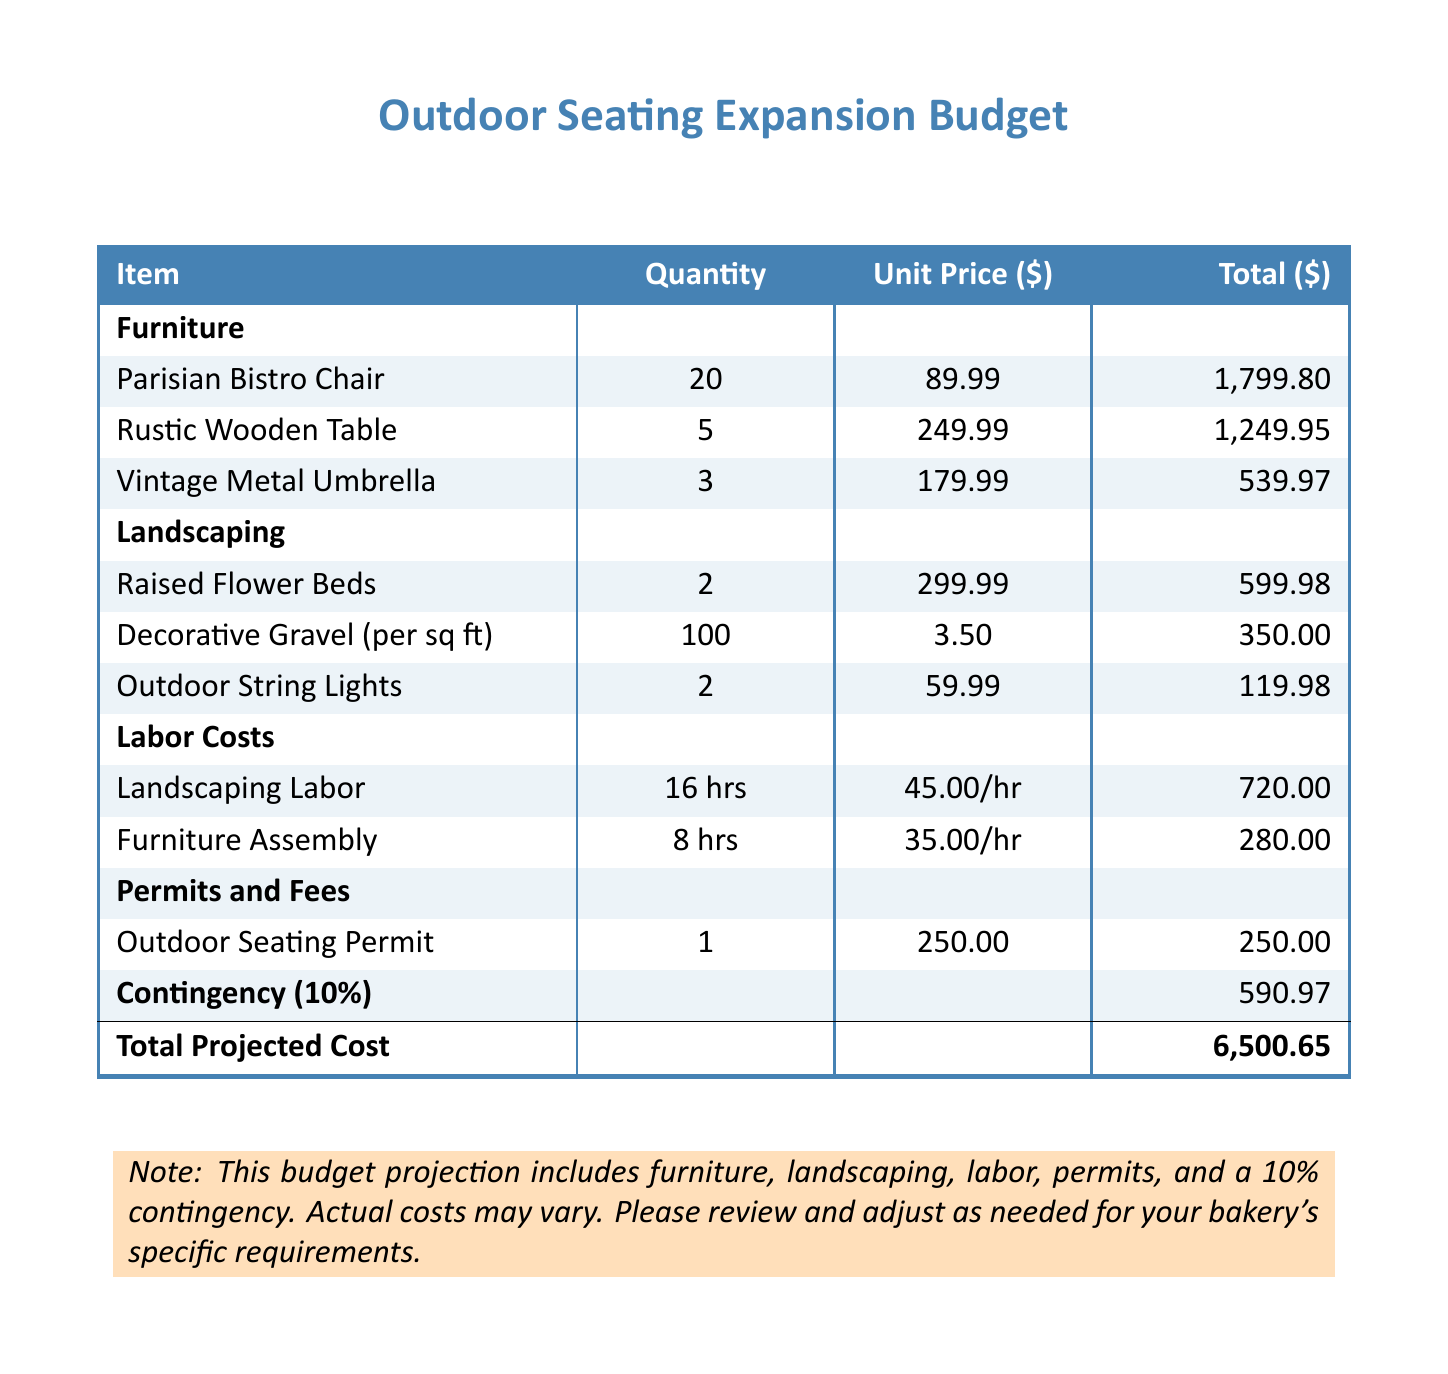What is the total projected cost? The total projected cost is stated at the bottom of the budget table as the final sum of all costs, which includes furniture, landscaping, labor, permits, and contingency.
Answer: 6,500.65 How many Rustic Wooden Tables are included? The quantity of Rustic Wooden Tables is listed under the furniture section of the budget.
Answer: 5 What is the unit price of a Parisian Bistro Chair? The unit price for a Parisian Bistro Chair can be found in the furniture section, next to the item listed.
Answer: 89.99 What is the total cost for Decorative Gravel? The total cost for Decorative Gravel is calculated by multiplying the quantity by the unit price, which is detailed in the budget.
Answer: 350.00 How much does Landscaping Labor cost per hour? The hourly rate for Landscaping Labor can be found in the labor costs section of the document.
Answer: 45.00 What is included in the contingency? The contingency is a percentage added to the total costs to cover unexpected expenses, indicated in the budget at 10%.
Answer: 590.97 What is the total number of items listed under landscaping? The total number of landscaping items can be counted from the landscaping section of the budget.
Answer: 3 How many hours are allocated for Furniture Assembly? The total hours allocated for Furniture Assembly are listed in the labor costs section under item description.
Answer: 8 What type of permit is included in the budget? The type of permit mentioned in the budget is specified in the permits and fees section.
Answer: Outdoor Seating Permit 